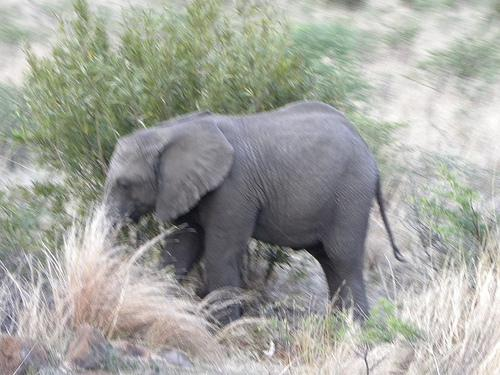Question: what color is the elephant?
Choices:
A. Gray.
B. Gunmetal.
C. Black.
D. White.
Answer with the letter. Answer: A Question: what is the elephant standing in?
Choices:
A. Grass.
B. A tree.
C. The mountain.
D. The water.
Answer with the letter. Answer: A Question: where was the picture taken?
Choices:
A. In front of the panda.
B. Near the tiger.
C. Close to elephant.
D. Next to the zebra.
Answer with the letter. Answer: C 